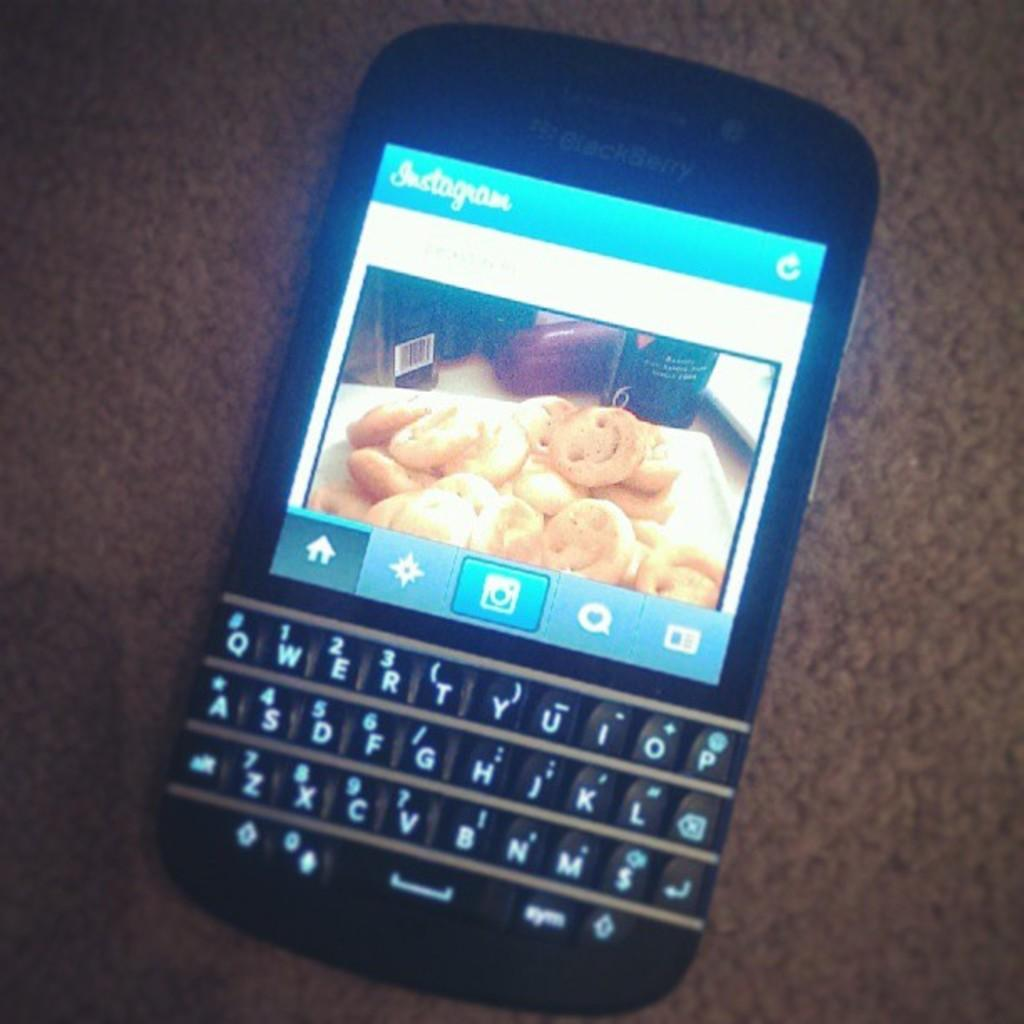<image>
Write a terse but informative summary of the picture. a photo that was put on the site of Instagram 